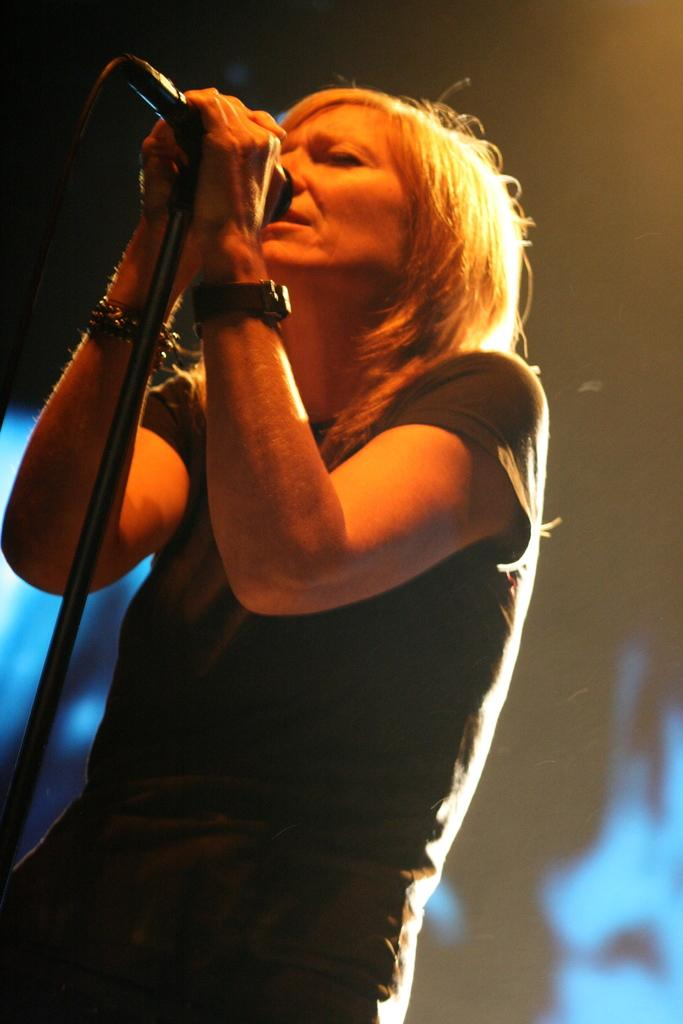Who is the main subject in the image? There is a lady in the image. What is the lady holding in the image? The lady is holding a mic. What is the lady doing in the image? The lady is singing. Can you describe the background of the image? The background of the image is blurred. How many trucks are visible in the image? There are no trucks present in the image. What type of cub is sitting on the stage in the image? There is no stage or cub present in the image. 